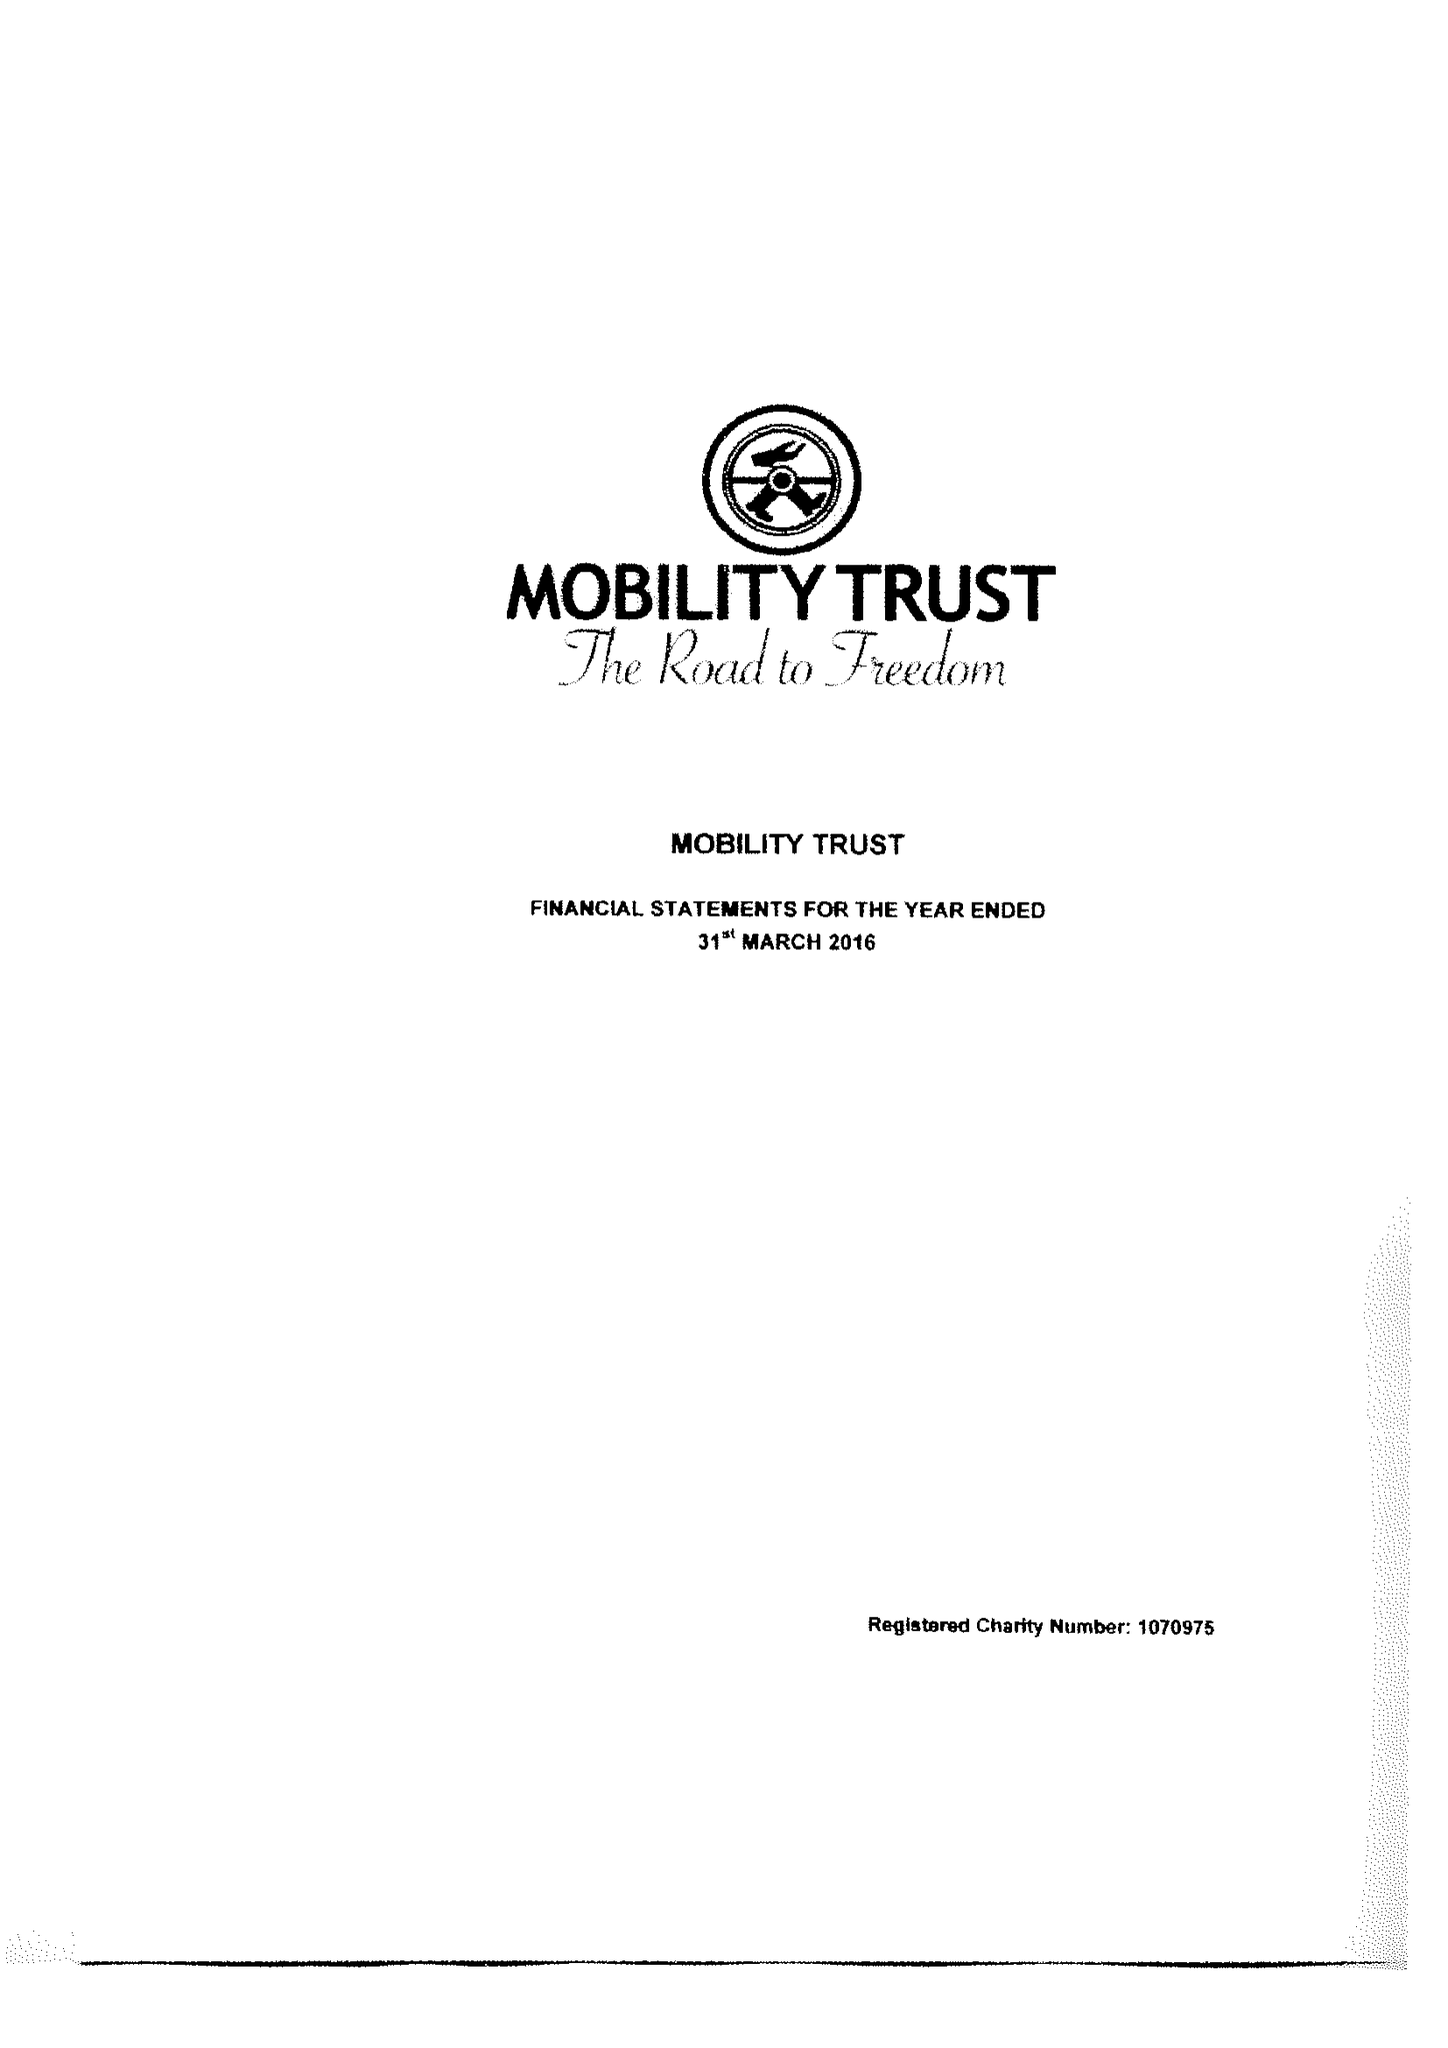What is the value for the address__street_line?
Answer the question using a single word or phrase. 19 READING ROAD 